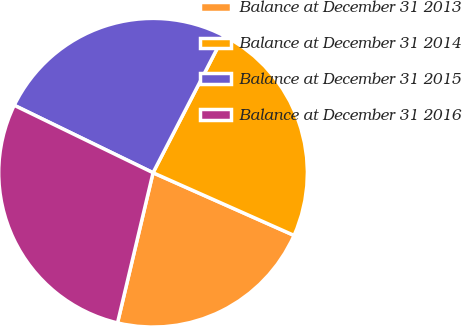<chart> <loc_0><loc_0><loc_500><loc_500><pie_chart><fcel>Balance at December 31 2013<fcel>Balance at December 31 2014<fcel>Balance at December 31 2015<fcel>Balance at December 31 2016<nl><fcel>22.04%<fcel>24.07%<fcel>25.39%<fcel>28.5%<nl></chart> 